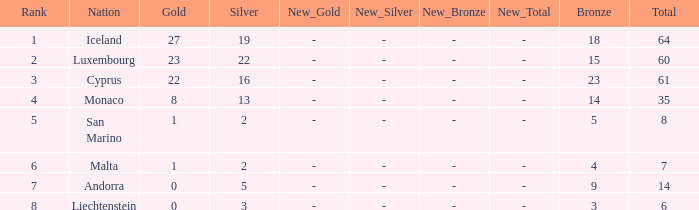How many bronzes for Iceland with over 2 silvers? 18.0. 